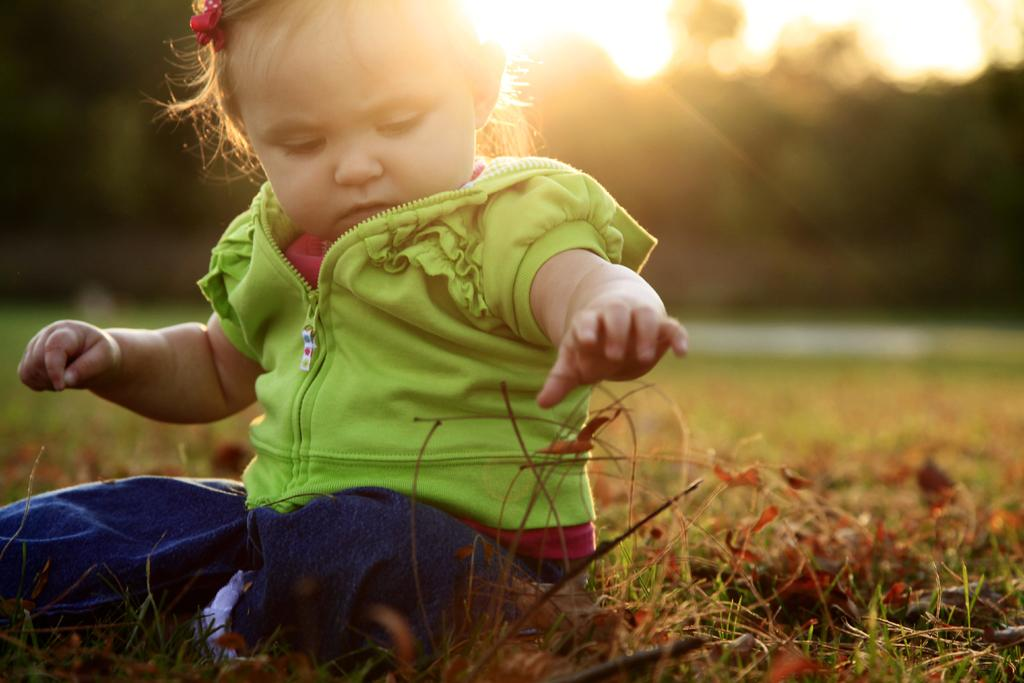Who or what is the main subject of the picture? The main subject of the picture is a child. What is the child doing in the picture? The child is sitting. What type of natural environment is visible in the picture? There is grass visible in the picture. Can you describe the background of the image? The background of the image is blurred. What can be seen in the sky in the picture? The sun is observable in the image. What type of band is performing in the background of the image? There is no band present in the image; it features a child sitting in a grassy area with a blurred background and the sun visible in the sky. 